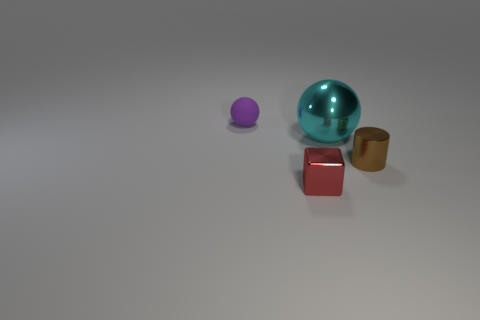Add 1 small things. How many objects exist? 5 Subtract all cylinders. How many objects are left? 3 Subtract 0 blue cubes. How many objects are left? 4 Subtract all big cyan metal things. Subtract all red things. How many objects are left? 2 Add 4 tiny balls. How many tiny balls are left? 5 Add 3 cyan spheres. How many cyan spheres exist? 4 